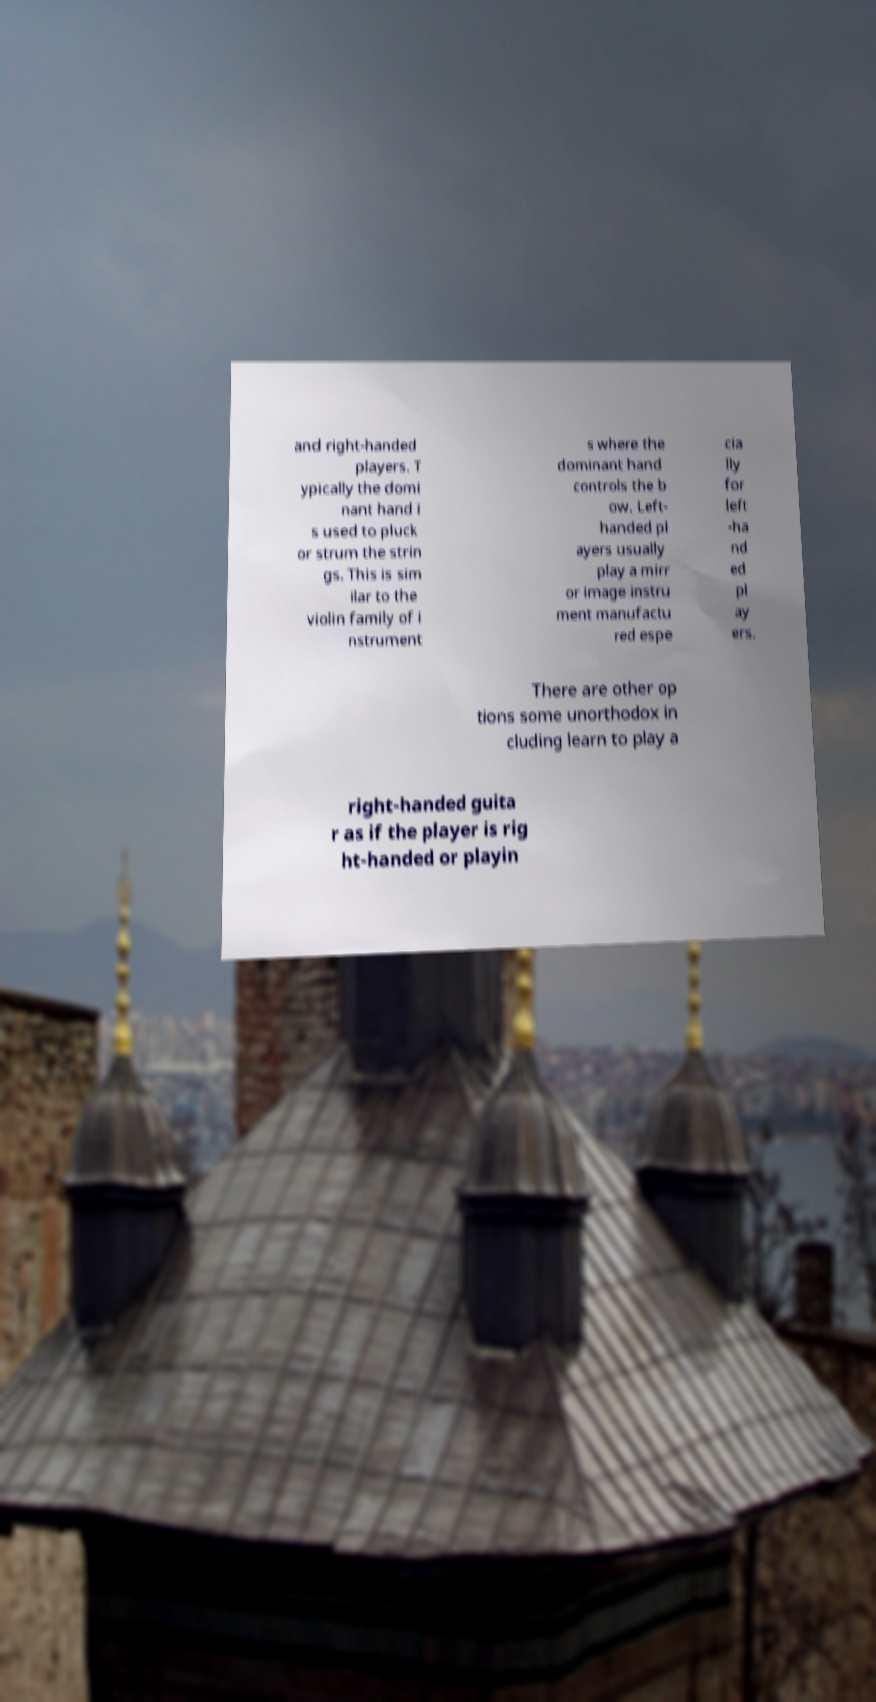Can you accurately transcribe the text from the provided image for me? and right-handed players. T ypically the domi nant hand i s used to pluck or strum the strin gs. This is sim ilar to the violin family of i nstrument s where the dominant hand controls the b ow. Left- handed pl ayers usually play a mirr or image instru ment manufactu red espe cia lly for left -ha nd ed pl ay ers. There are other op tions some unorthodox in cluding learn to play a right-handed guita r as if the player is rig ht-handed or playin 